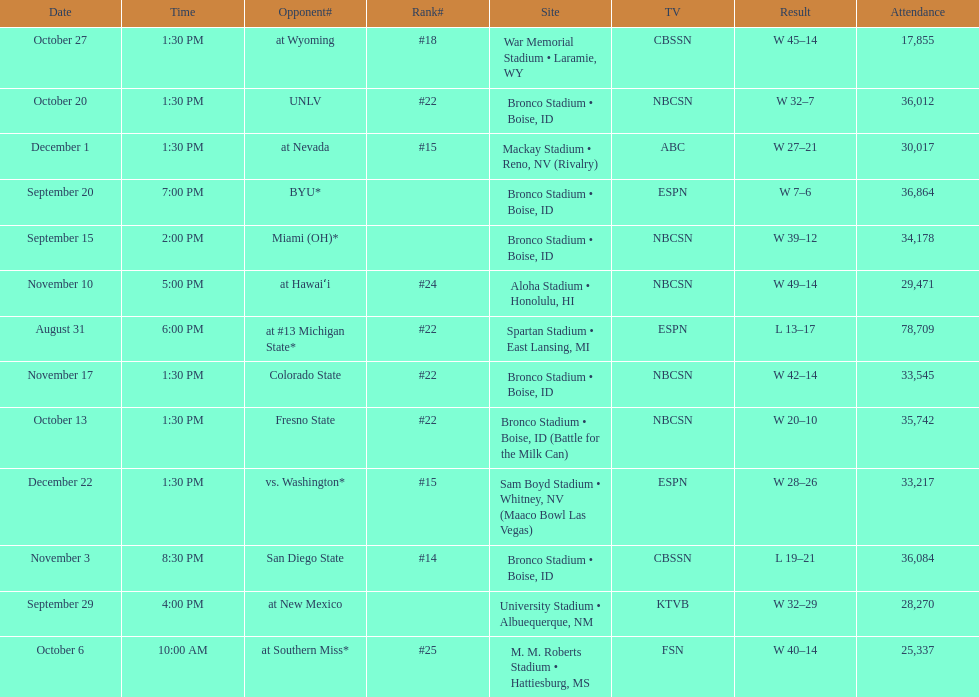Add up the total number of points scored in the last wins for boise state. 146. 